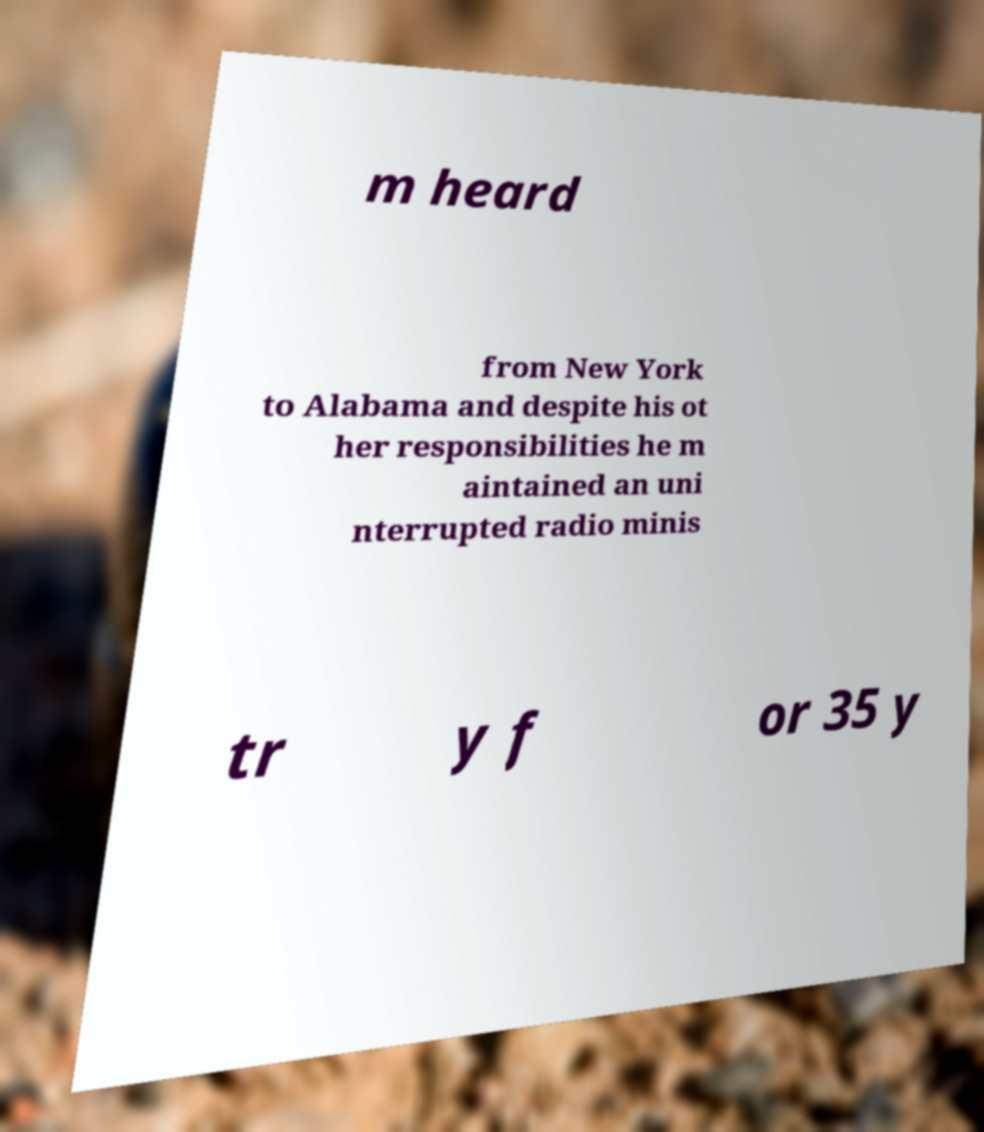Can you read and provide the text displayed in the image?This photo seems to have some interesting text. Can you extract and type it out for me? m heard from New York to Alabama and despite his ot her responsibilities he m aintained an uni nterrupted radio minis tr y f or 35 y 